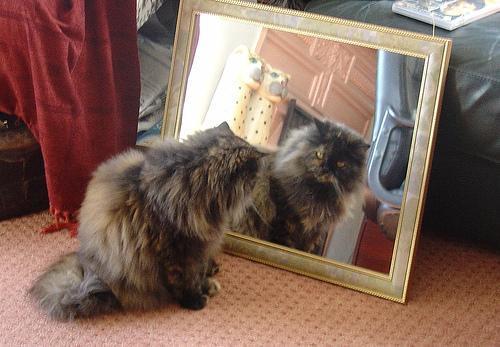How many cats are there?
Give a very brief answer. 1. 